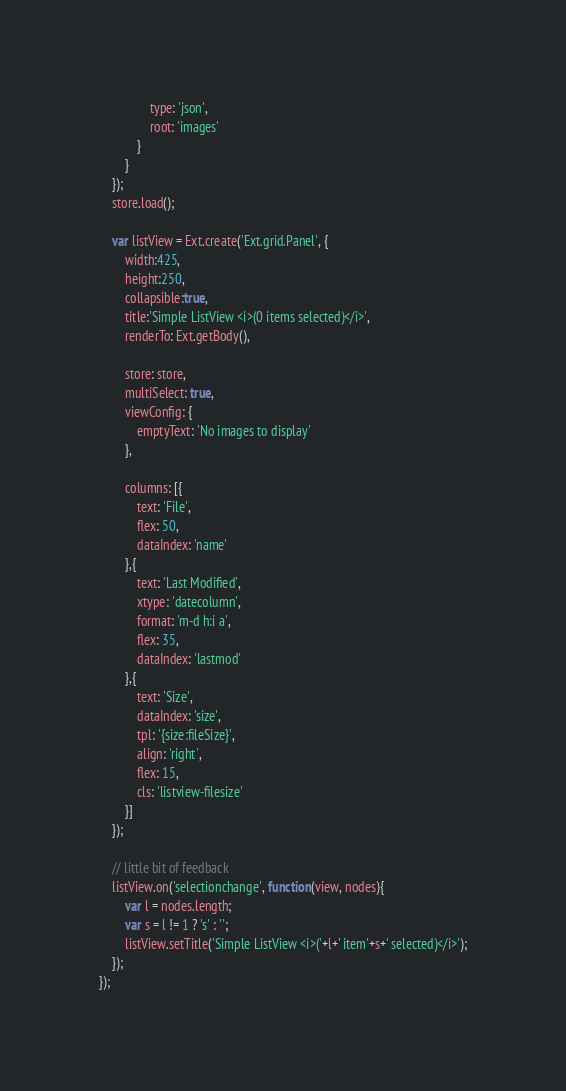Convert code to text. <code><loc_0><loc_0><loc_500><loc_500><_JavaScript_>                type: 'json',
                root: 'images'
            }
        }
    });
    store.load();

    var listView = Ext.create('Ext.grid.Panel', {
        width:425,
        height:250,
        collapsible:true,
        title:'Simple ListView <i>(0 items selected)</i>',
        renderTo: Ext.getBody(),

        store: store,
        multiSelect: true,
        viewConfig: {
            emptyText: 'No images to display'
        },

        columns: [{
            text: 'File',
            flex: 50,
            dataIndex: 'name'
        },{
            text: 'Last Modified',
            xtype: 'datecolumn',
            format: 'm-d h:i a',
            flex: 35,
            dataIndex: 'lastmod'
        },{
            text: 'Size',
            dataIndex: 'size',
            tpl: '{size:fileSize}',
            align: 'right',
            flex: 15,
            cls: 'listview-filesize'
        }]
    });

    // little bit of feedback
    listView.on('selectionchange', function(view, nodes){
        var l = nodes.length;
        var s = l != 1 ? 's' : '';
        listView.setTitle('Simple ListView <i>('+l+' item'+s+' selected)</i>');
    });
});

</code> 